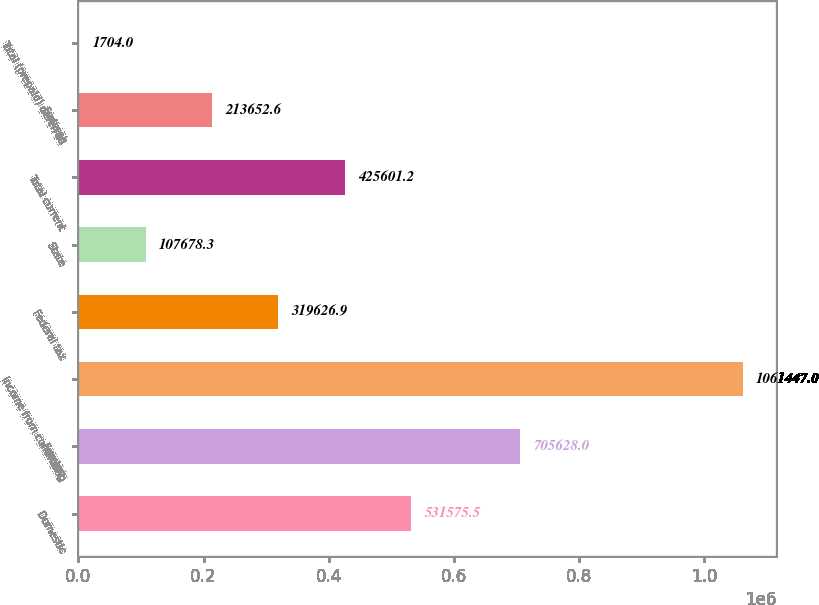<chart> <loc_0><loc_0><loc_500><loc_500><bar_chart><fcel>Domestic<fcel>Foreign<fcel>Income from continuing<fcel>Federal tax<fcel>State<fcel>Total current<fcel>Federal<fcel>Total (prepaid) deferred<nl><fcel>531576<fcel>705628<fcel>1.06145e+06<fcel>319627<fcel>107678<fcel>425601<fcel>213653<fcel>1704<nl></chart> 